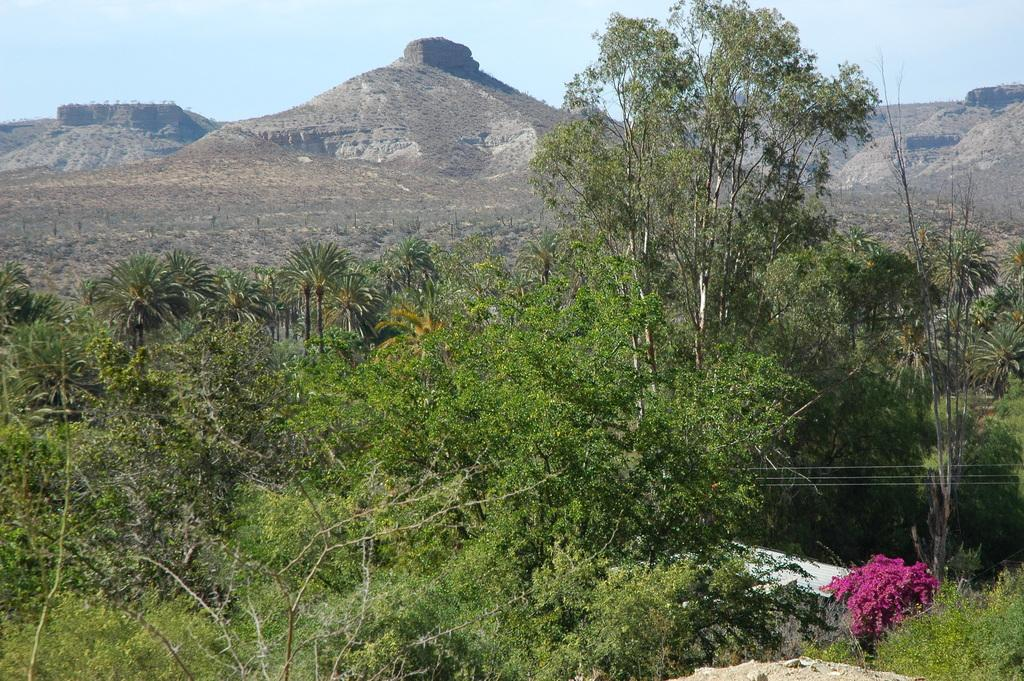What type of vegetation can be seen in the image? There are trees and plants in the image. What geographical feature is present in the image? There is a hill in the image. What is the condition of the sky in the image? The sky is cloudy in the image. Can you hear the sound of thunder in the image? There is no sound present in the image, so it is not possible to determine if there is thunder. 